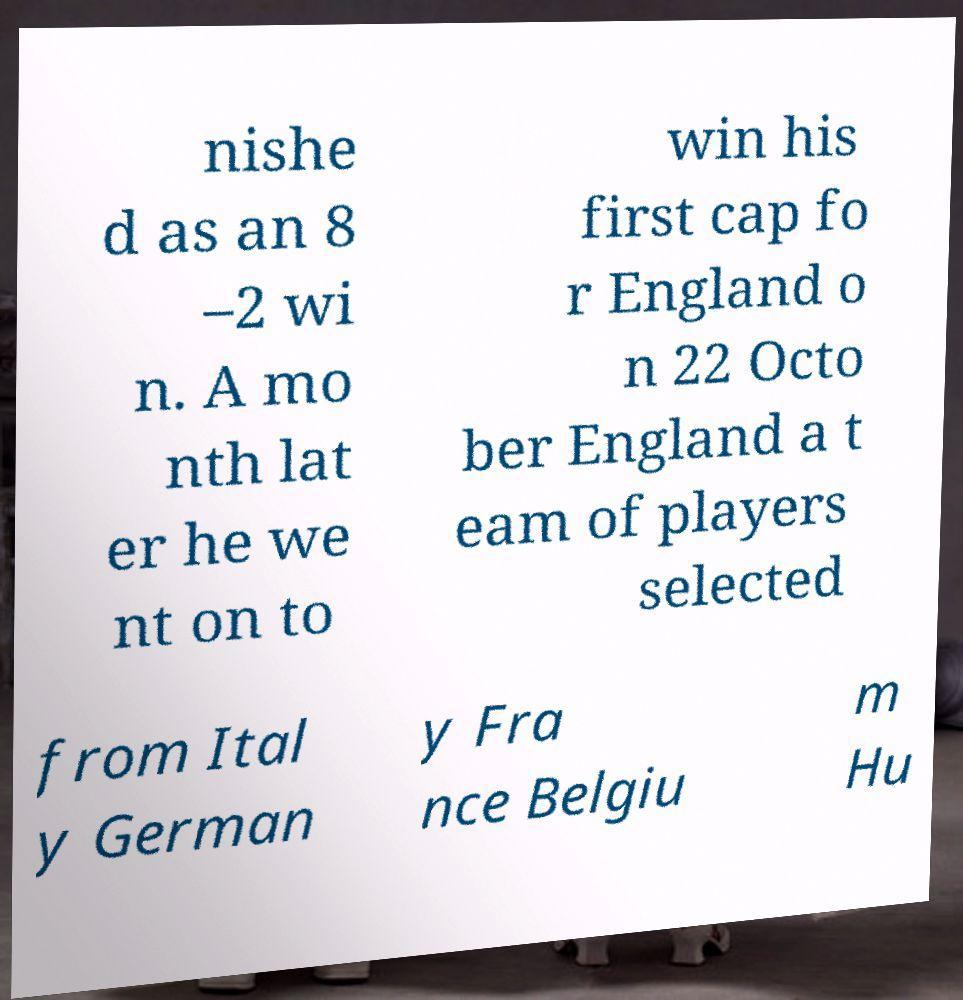Can you accurately transcribe the text from the provided image for me? nishe d as an 8 –2 wi n. A mo nth lat er he we nt on to win his first cap fo r England o n 22 Octo ber England a t eam of players selected from Ital y German y Fra nce Belgiu m Hu 